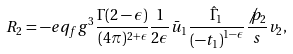Convert formula to latex. <formula><loc_0><loc_0><loc_500><loc_500>R _ { 2 } = - e q _ { f } g ^ { 3 } \frac { \Gamma ( 2 - \epsilon ) } { ( 4 \pi ) ^ { 2 + \epsilon } } \frac { 1 } { 2 \epsilon } \bar { u } _ { 1 } \frac { \hat { \Gamma } _ { 1 } } { \left ( - t _ { 1 } \right ) ^ { 1 - \epsilon } } \frac { \not p _ { 2 } } { s } v _ { 2 } ,</formula> 